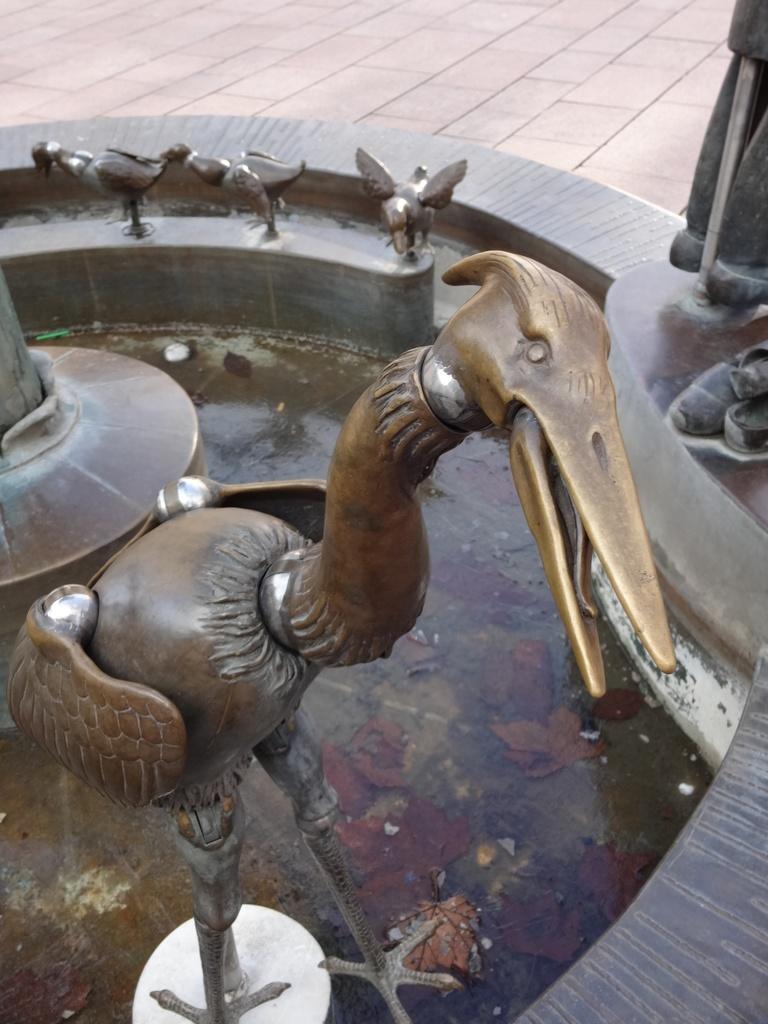Could you give a brief overview of what you see in this image? In this image there is a fountain, in that fountain there is a metal bird, in the background there are three metal birds. 